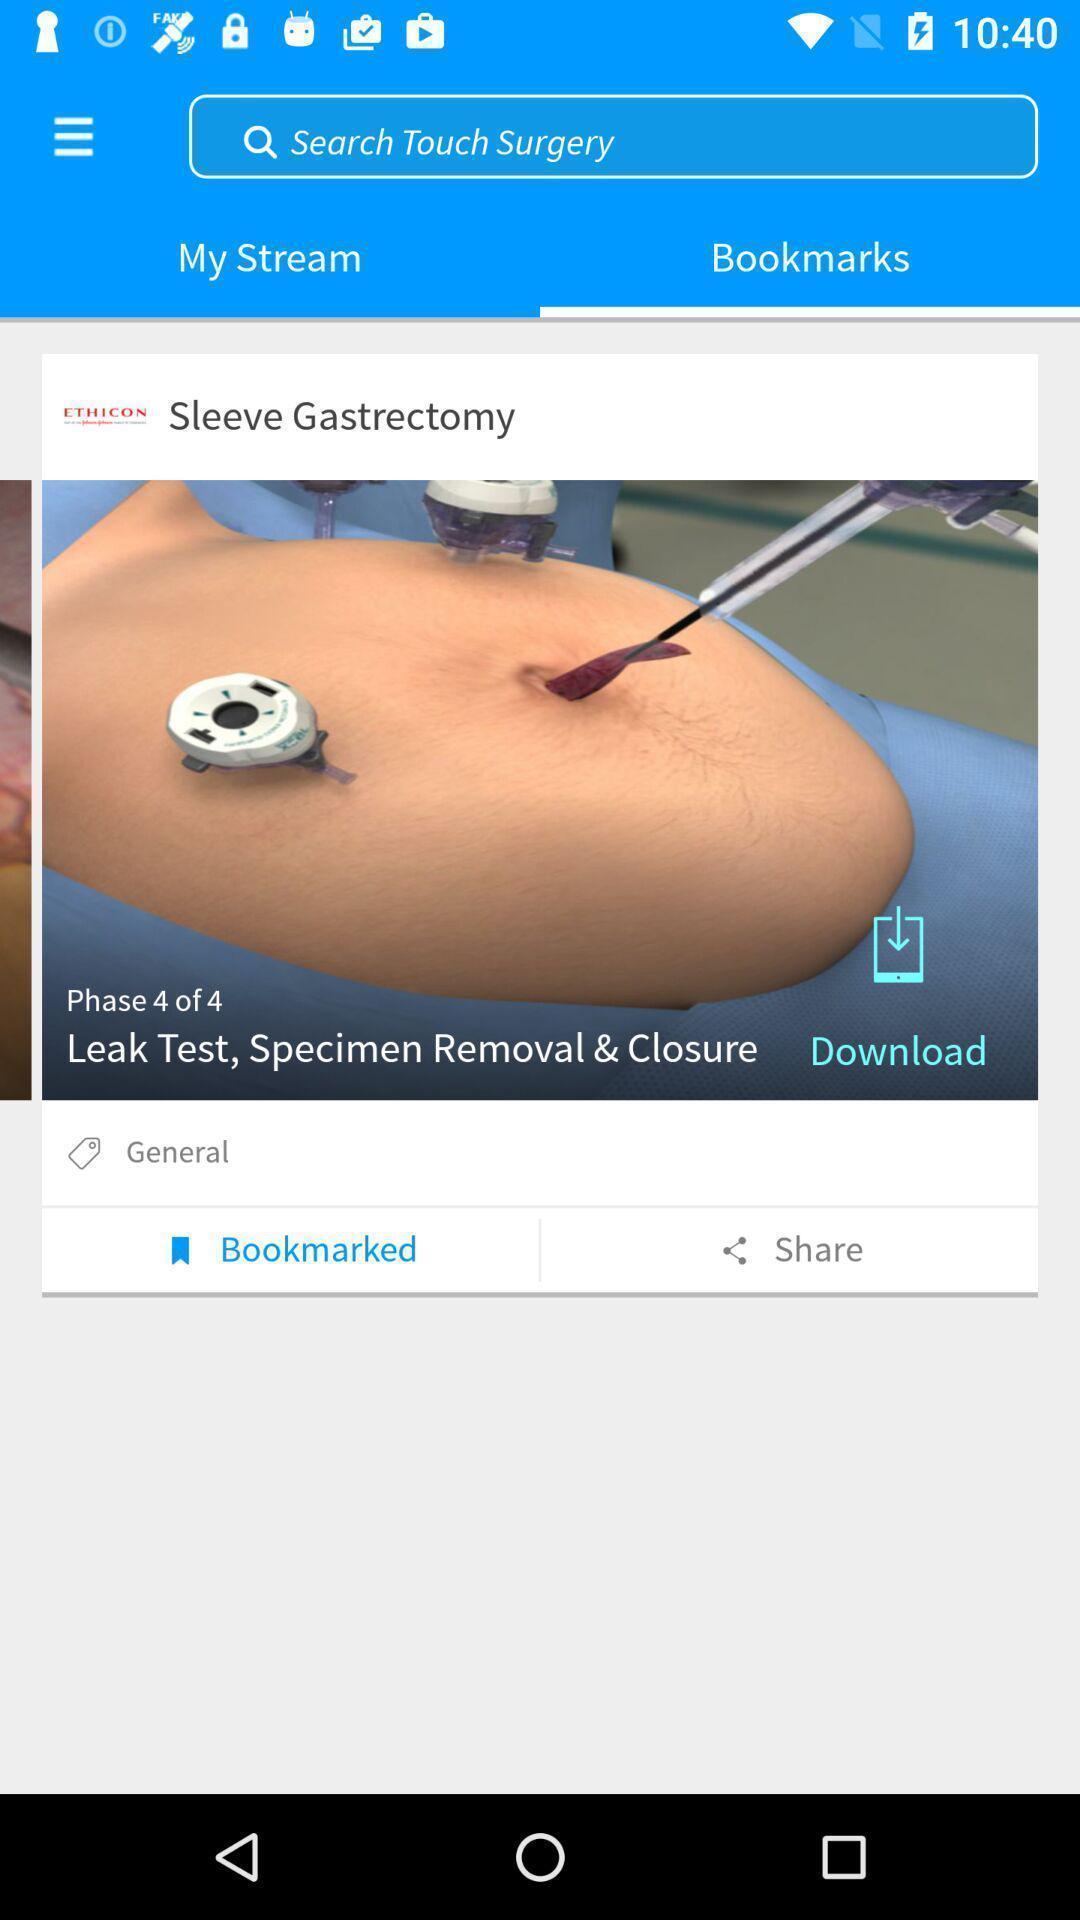Provide a detailed account of this screenshot. Screen displaying the bookmarks page. 